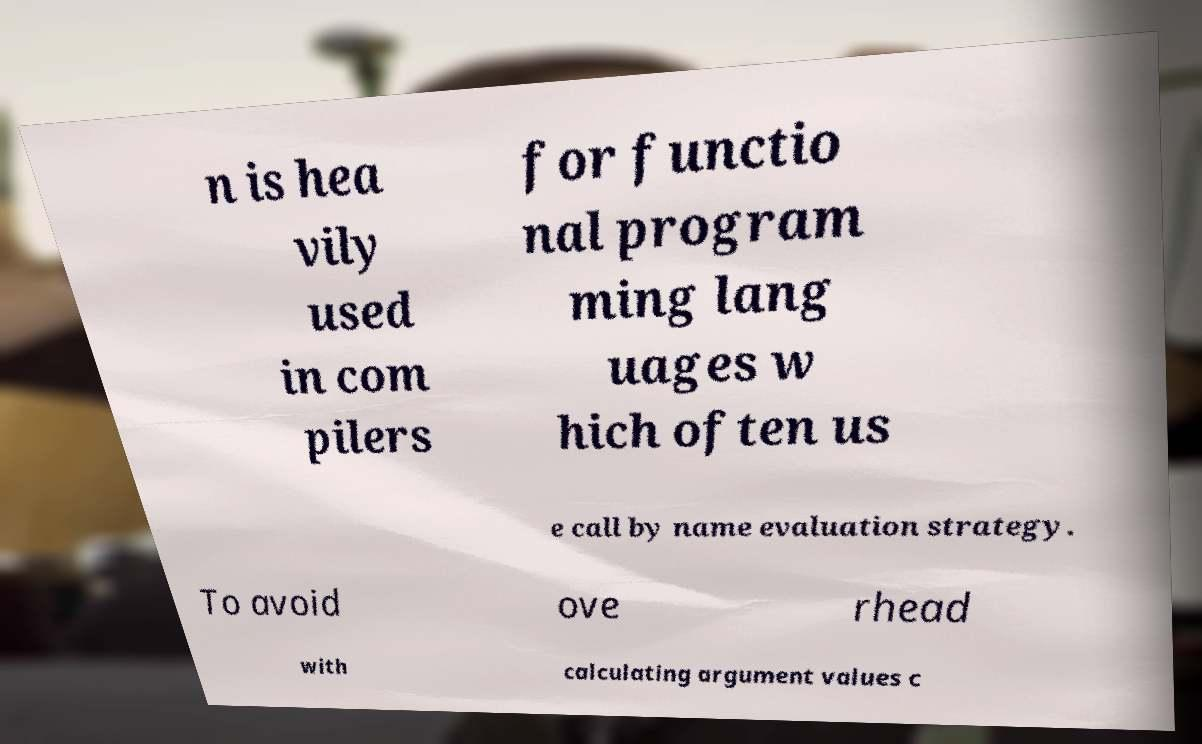What messages or text are displayed in this image? I need them in a readable, typed format. n is hea vily used in com pilers for functio nal program ming lang uages w hich often us e call by name evaluation strategy. To avoid ove rhead with calculating argument values c 